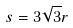Convert formula to latex. <formula><loc_0><loc_0><loc_500><loc_500>s = 3 \sqrt { 3 } r</formula> 